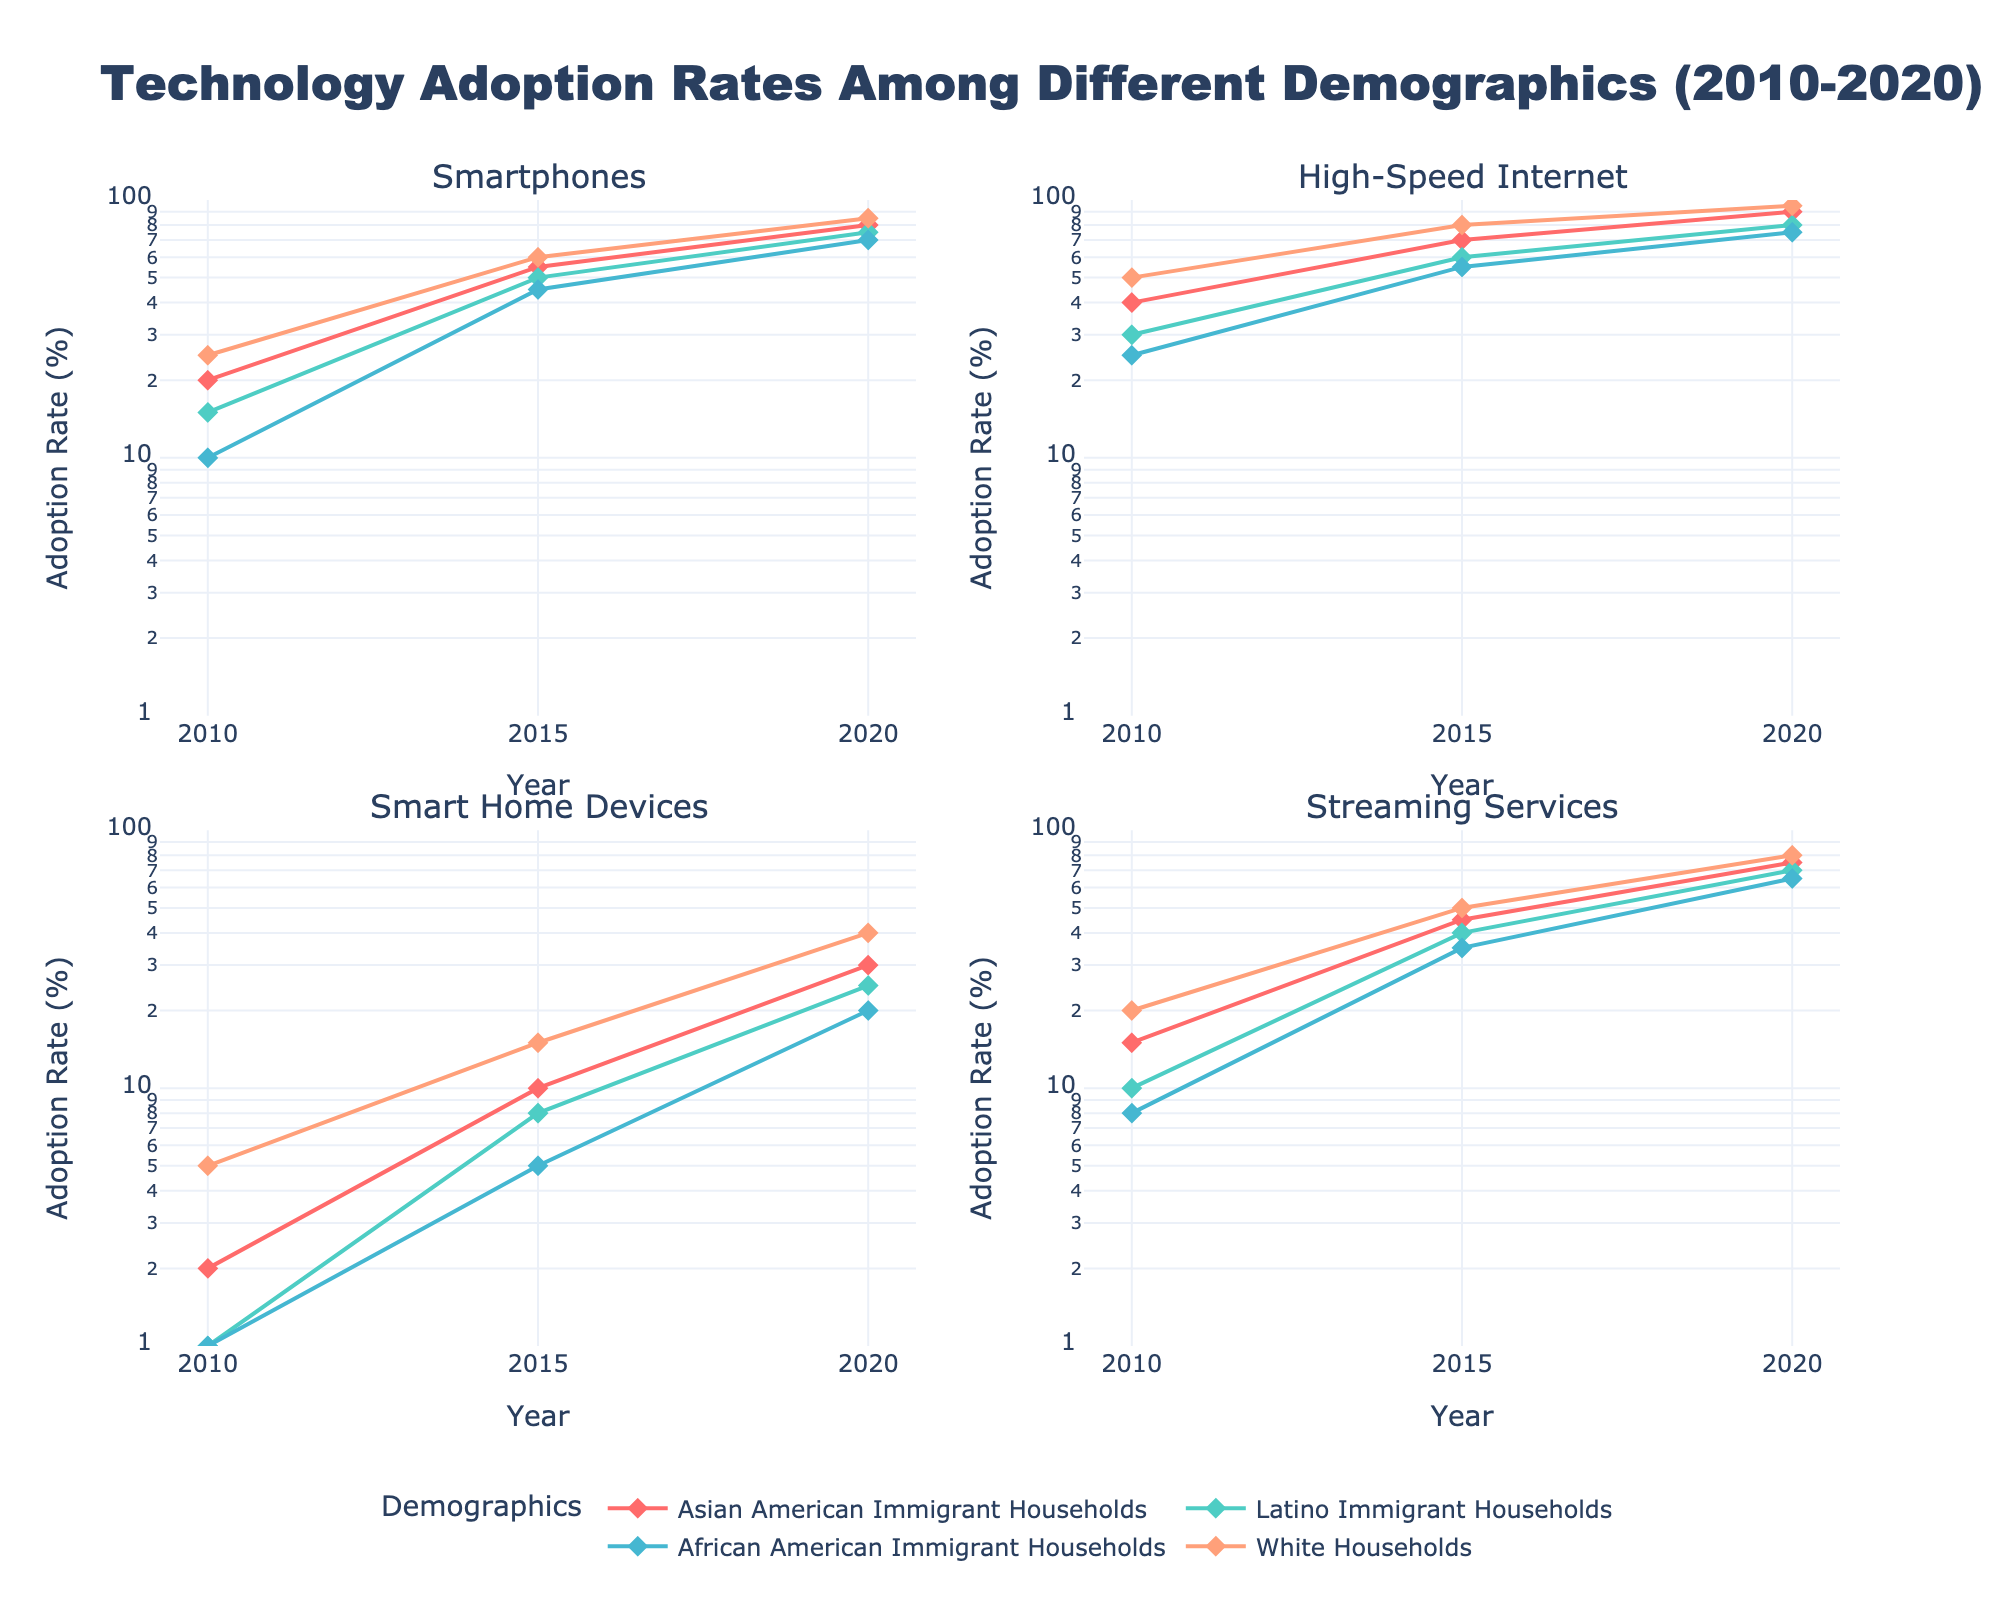What is the title of the figure? The title of the figure is prominently displayed at the top. It states, "Technology Adoption Rates Among Different Demographics (2010-2020)"
Answer: Technology Adoption Rates Among Different Demographics (2010-2020) What are the four technologies plotted in the subplots? The subplot titles indicate the four technologies being plotted: Smartphones, High-Speed Internet, Smart Home Devices, and Streaming Services.
Answer: Smartphones, High-Speed Internet, Smart Home Devices, Streaming Services Which demographic group had the highest adoption rate of smartphones in 2020? In the subplot for Smartphones, the line with the highest endpoint (2020) is colored for White Households, indicating the highest adoption rate.
Answer: White Households How did the adoption rate for Smart Home Devices in Latino Immigrant Households change from 2010 to 2020? In the subplot for Smart Home Devices, the line representing Latino Immigrant Households advances from 1% in 2010 to 25% in 2020.
Answer: Increased from 1% to 25% Which demographic group saw the largest increase in High-Speed Internet adoption between 2010 and 2020? By comparing the vertical distances on the High-Speed Internet subplot, Asian American Immigrant Households saw the largest increase from 40% in 2010 to 90% in 2020.
Answer: Asian American Immigrant Households What was the adoption rate of Streaming Services among African American Immigrant Households in 2015? On the Streaming Services subplot, the point corresponding to 2015 for African American Immigrant Households is at 35%.
Answer: 35% Compare the adoption rates of Smart Home Devices in 2020 among the different demographics. Which group lags the most? By comparing the endpoints (2020) on the Smart Home Devices subplot, African American Immigrant Households are the lowest at around 20%.
Answer: African American Immigrant Households In which year did White Households have the same adoption rate for Smartphones and High-Speed Internet? On the Smartphone and High-Speed Internet subplots, both endpoints (2015) for White Households align at around 60%.
Answer: 2015 What is the log scale range used for the y-axes across all subplots? The y-axes on all subplots are set to a log scale, ranging from 0 to 2. This is consistent across all four subplots.
Answer: 0 to 2 Which demographic group had the smallest increase in the adoption rate of Streaming Services from 2010 to 2020? By comparing the vertical distances in the Streaming Services subplot, Latino Immigrant Households had an increase from 10% in 2010 to 70% in 2020, the smallest increase amongst groups.
Answer: Latino Immigrant Households 